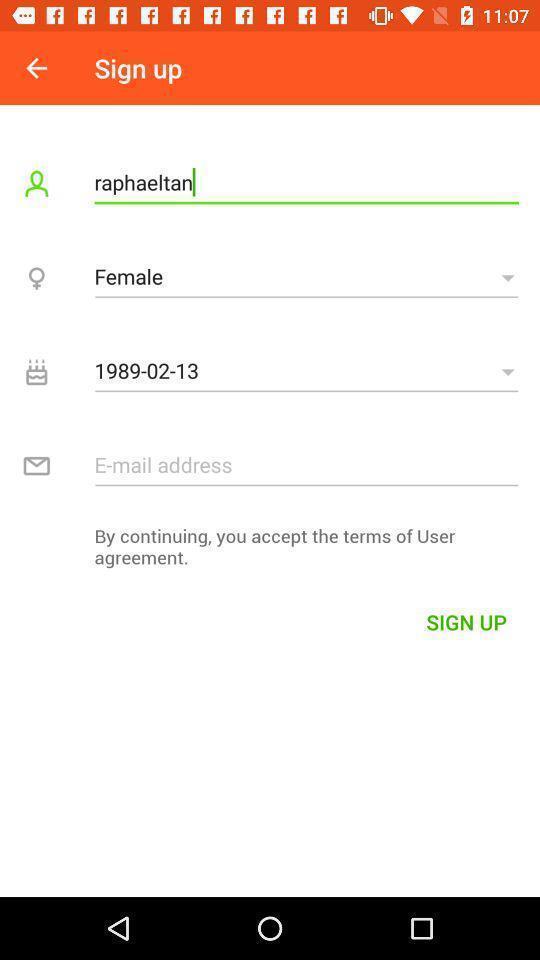Explain what's happening in this screen capture. Sign up page displayed of an dating application. 